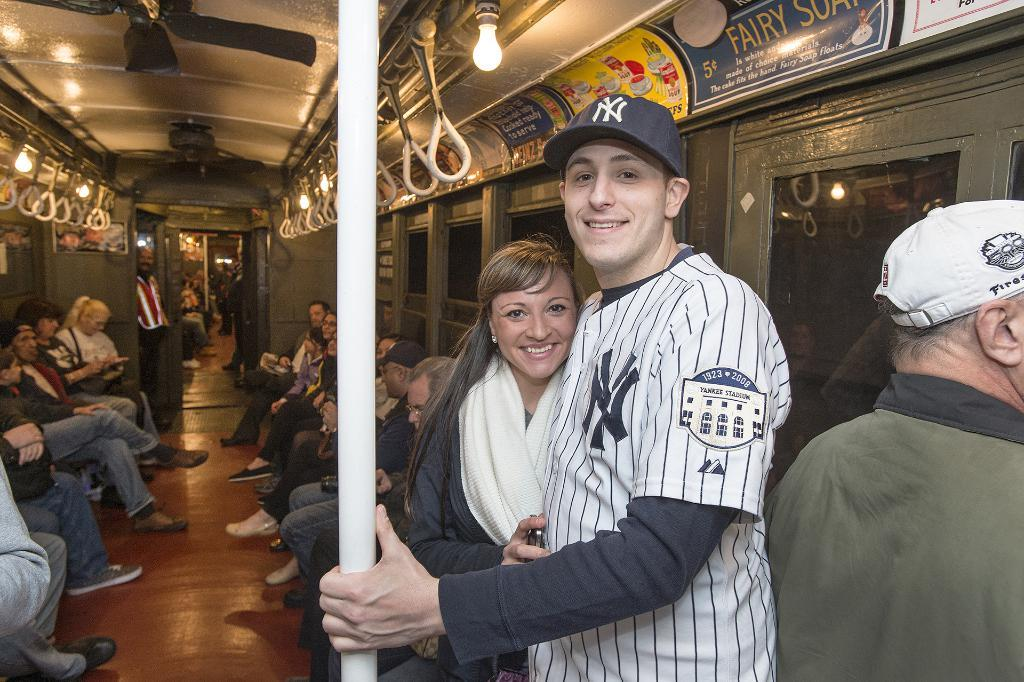<image>
Share a concise interpretation of the image provided. A couple standing on a subway train with the man wearing a NY Yankees jersey and hat. 